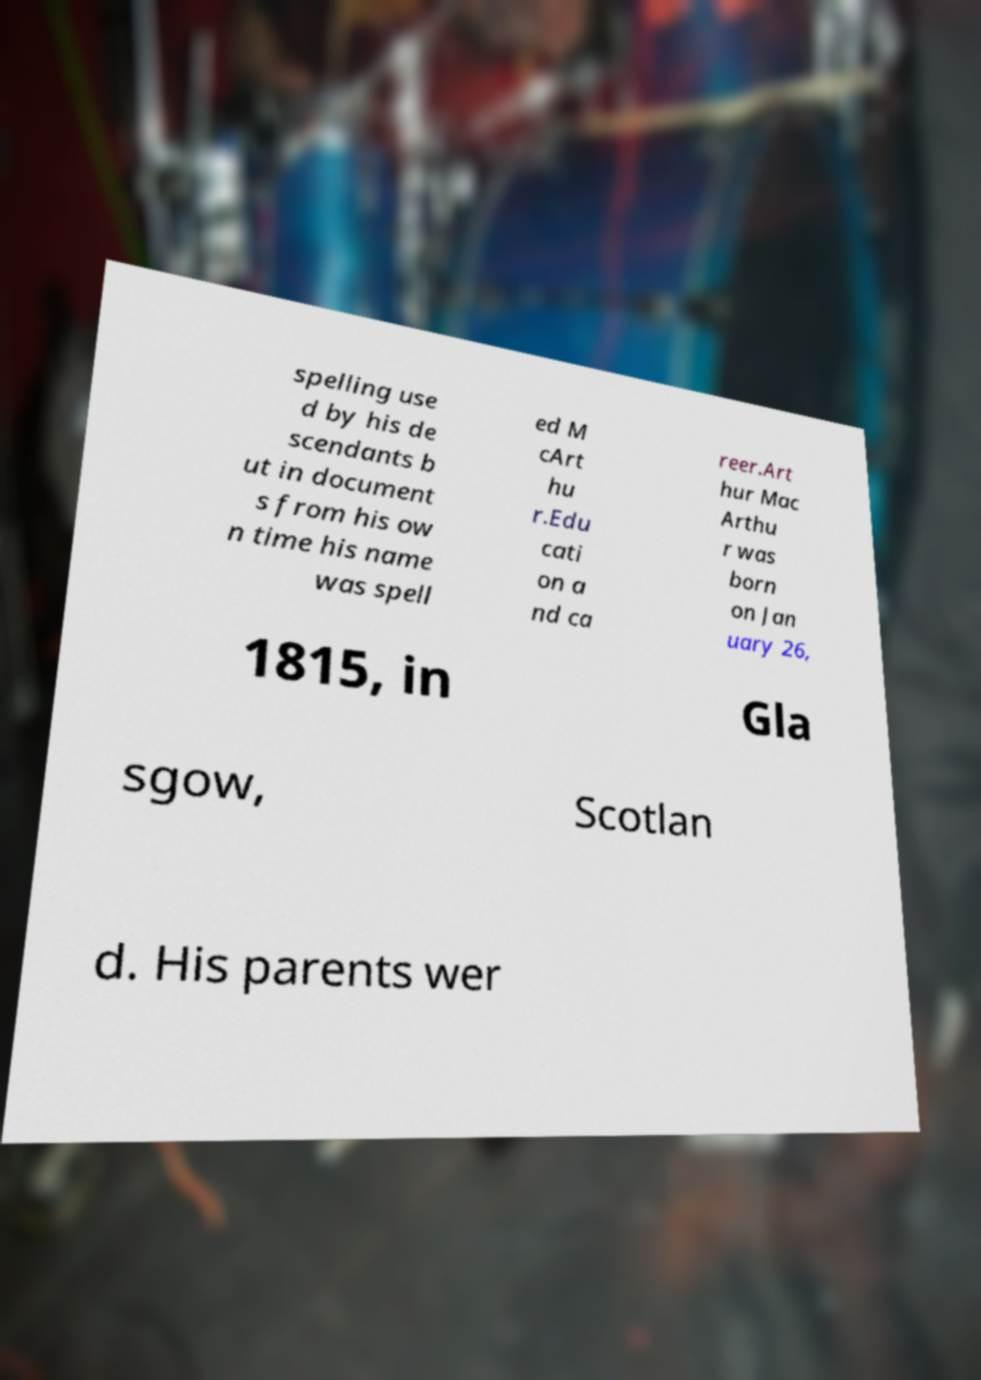There's text embedded in this image that I need extracted. Can you transcribe it verbatim? spelling use d by his de scendants b ut in document s from his ow n time his name was spell ed M cArt hu r.Edu cati on a nd ca reer.Art hur Mac Arthu r was born on Jan uary 26, 1815, in Gla sgow, Scotlan d. His parents wer 